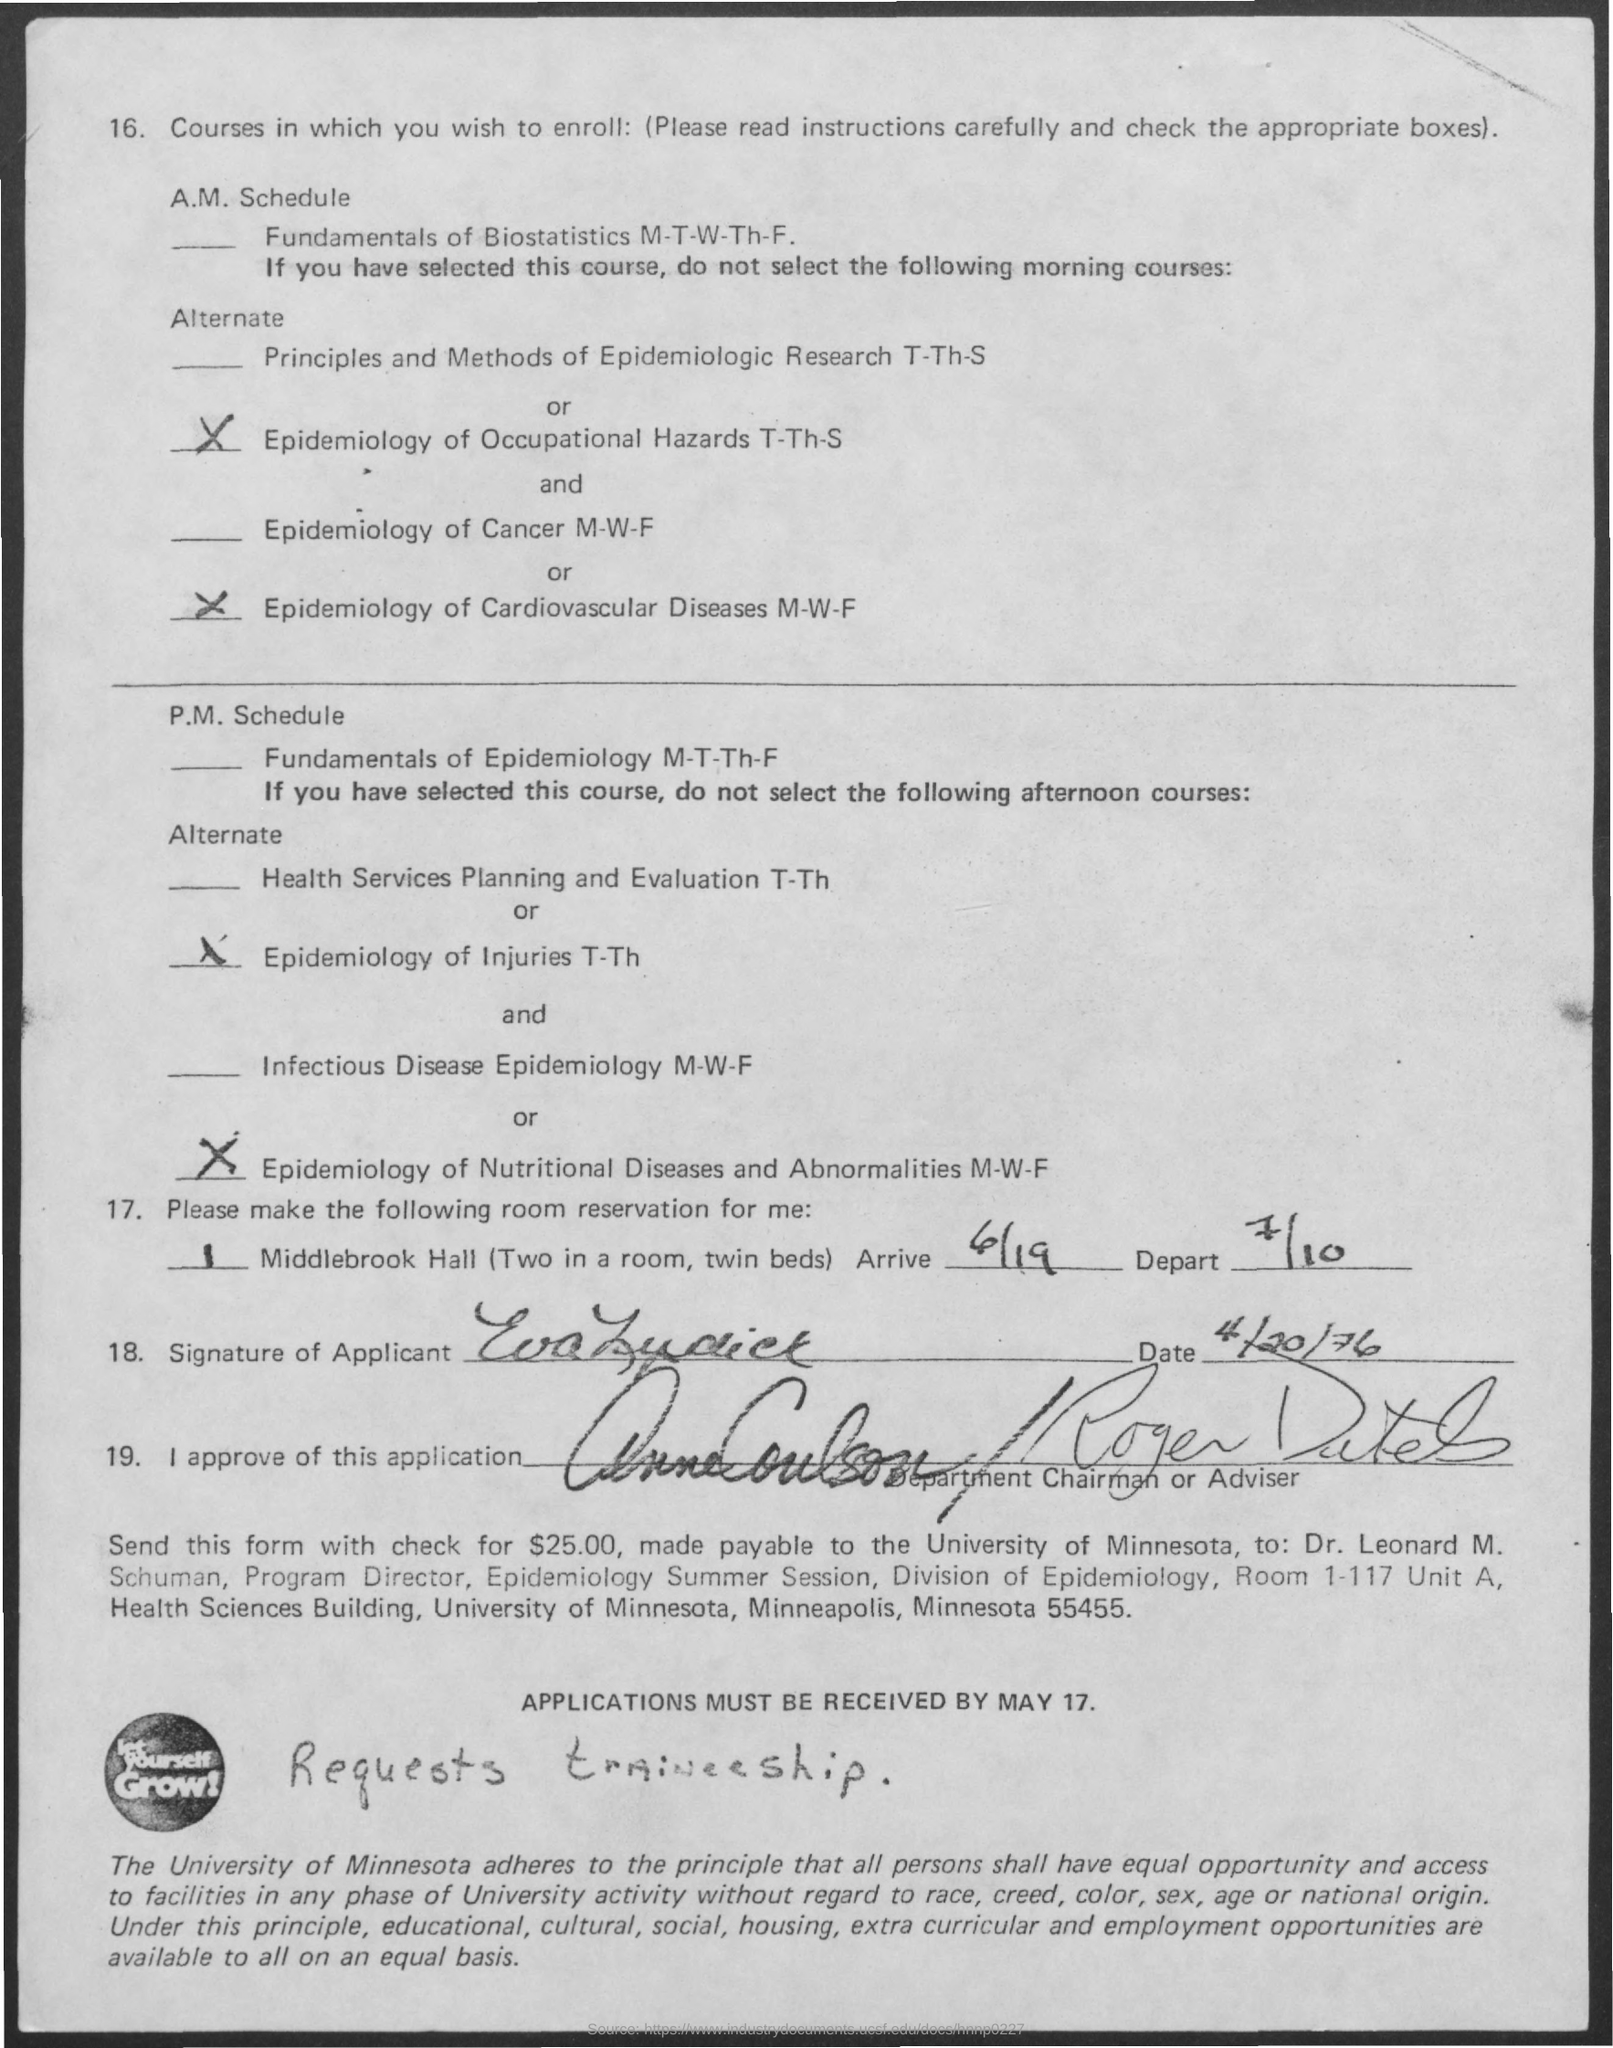What is the date for "arrive"?
Ensure brevity in your answer.  6/19. What is the date for "depart"?
Ensure brevity in your answer.  7/10. What is the date on the application?
Ensure brevity in your answer.  4/20/76. When should the application be received by?
Offer a very short reply. May 17. 